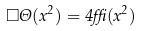<formula> <loc_0><loc_0><loc_500><loc_500>\Box \Theta ( x ^ { 2 } ) = 4 \delta ( x ^ { 2 } )</formula> 